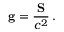<formula> <loc_0><loc_0><loc_500><loc_500>g = { \frac { S } { c ^ { 2 } } } \, .</formula> 